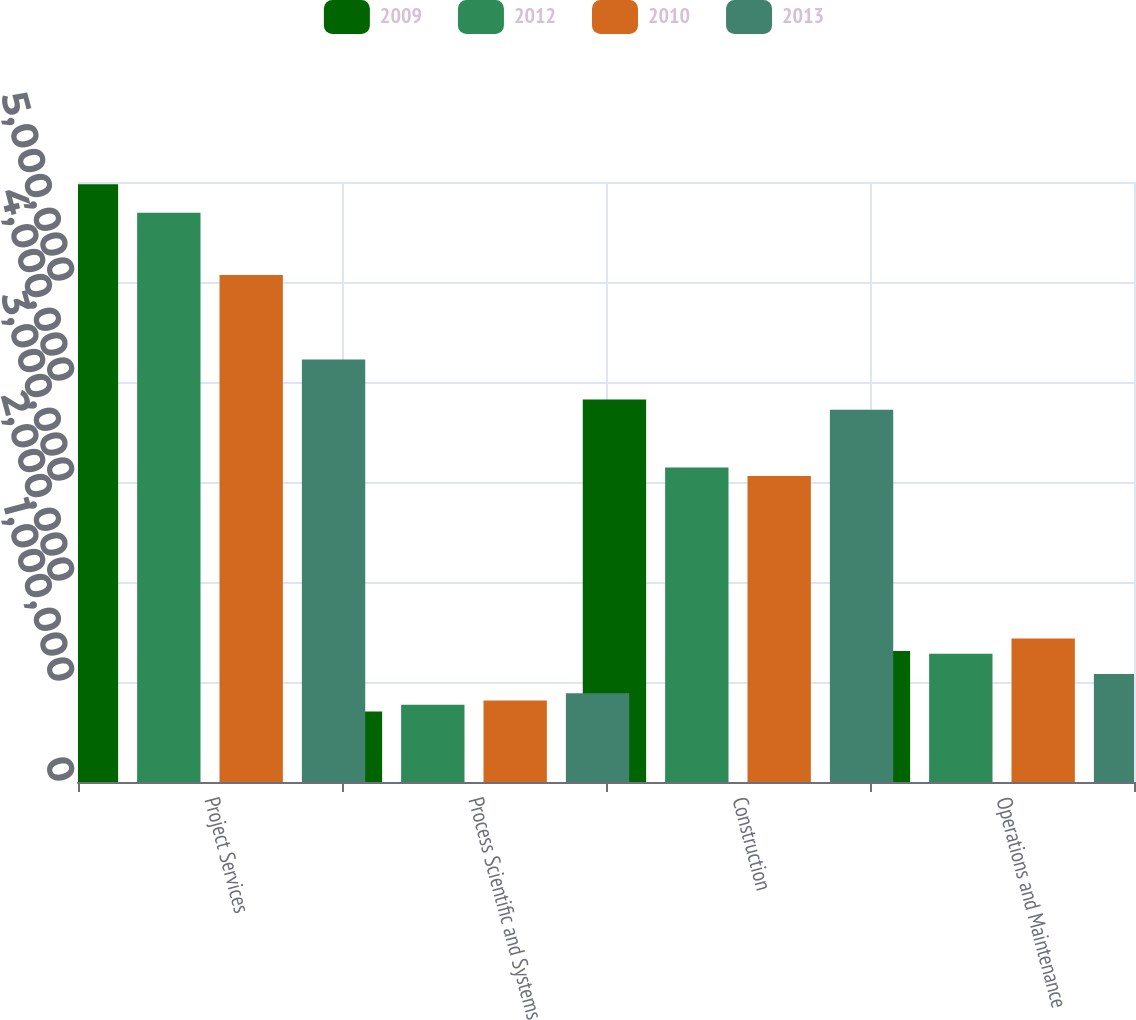<chart> <loc_0><loc_0><loc_500><loc_500><stacked_bar_chart><ecel><fcel>Project Services<fcel>Process Scientific and Systems<fcel>Construction<fcel>Operations and Maintenance<nl><fcel>2009<fcel>5.97792e+06<fcel>705694<fcel>3.82588e+06<fcel>1.30889e+06<nl><fcel>2012<fcel>5.69342e+06<fcel>772031<fcel>3.14531e+06<fcel>1.28302e+06<nl><fcel>2010<fcel>5.07058e+06<fcel>815561<fcel>3.06082e+06<fcel>1.43471e+06<nl><fcel>2013<fcel>4.2249e+06<fcel>888405<fcel>3.7221e+06<fcel>1.08011e+06<nl></chart> 